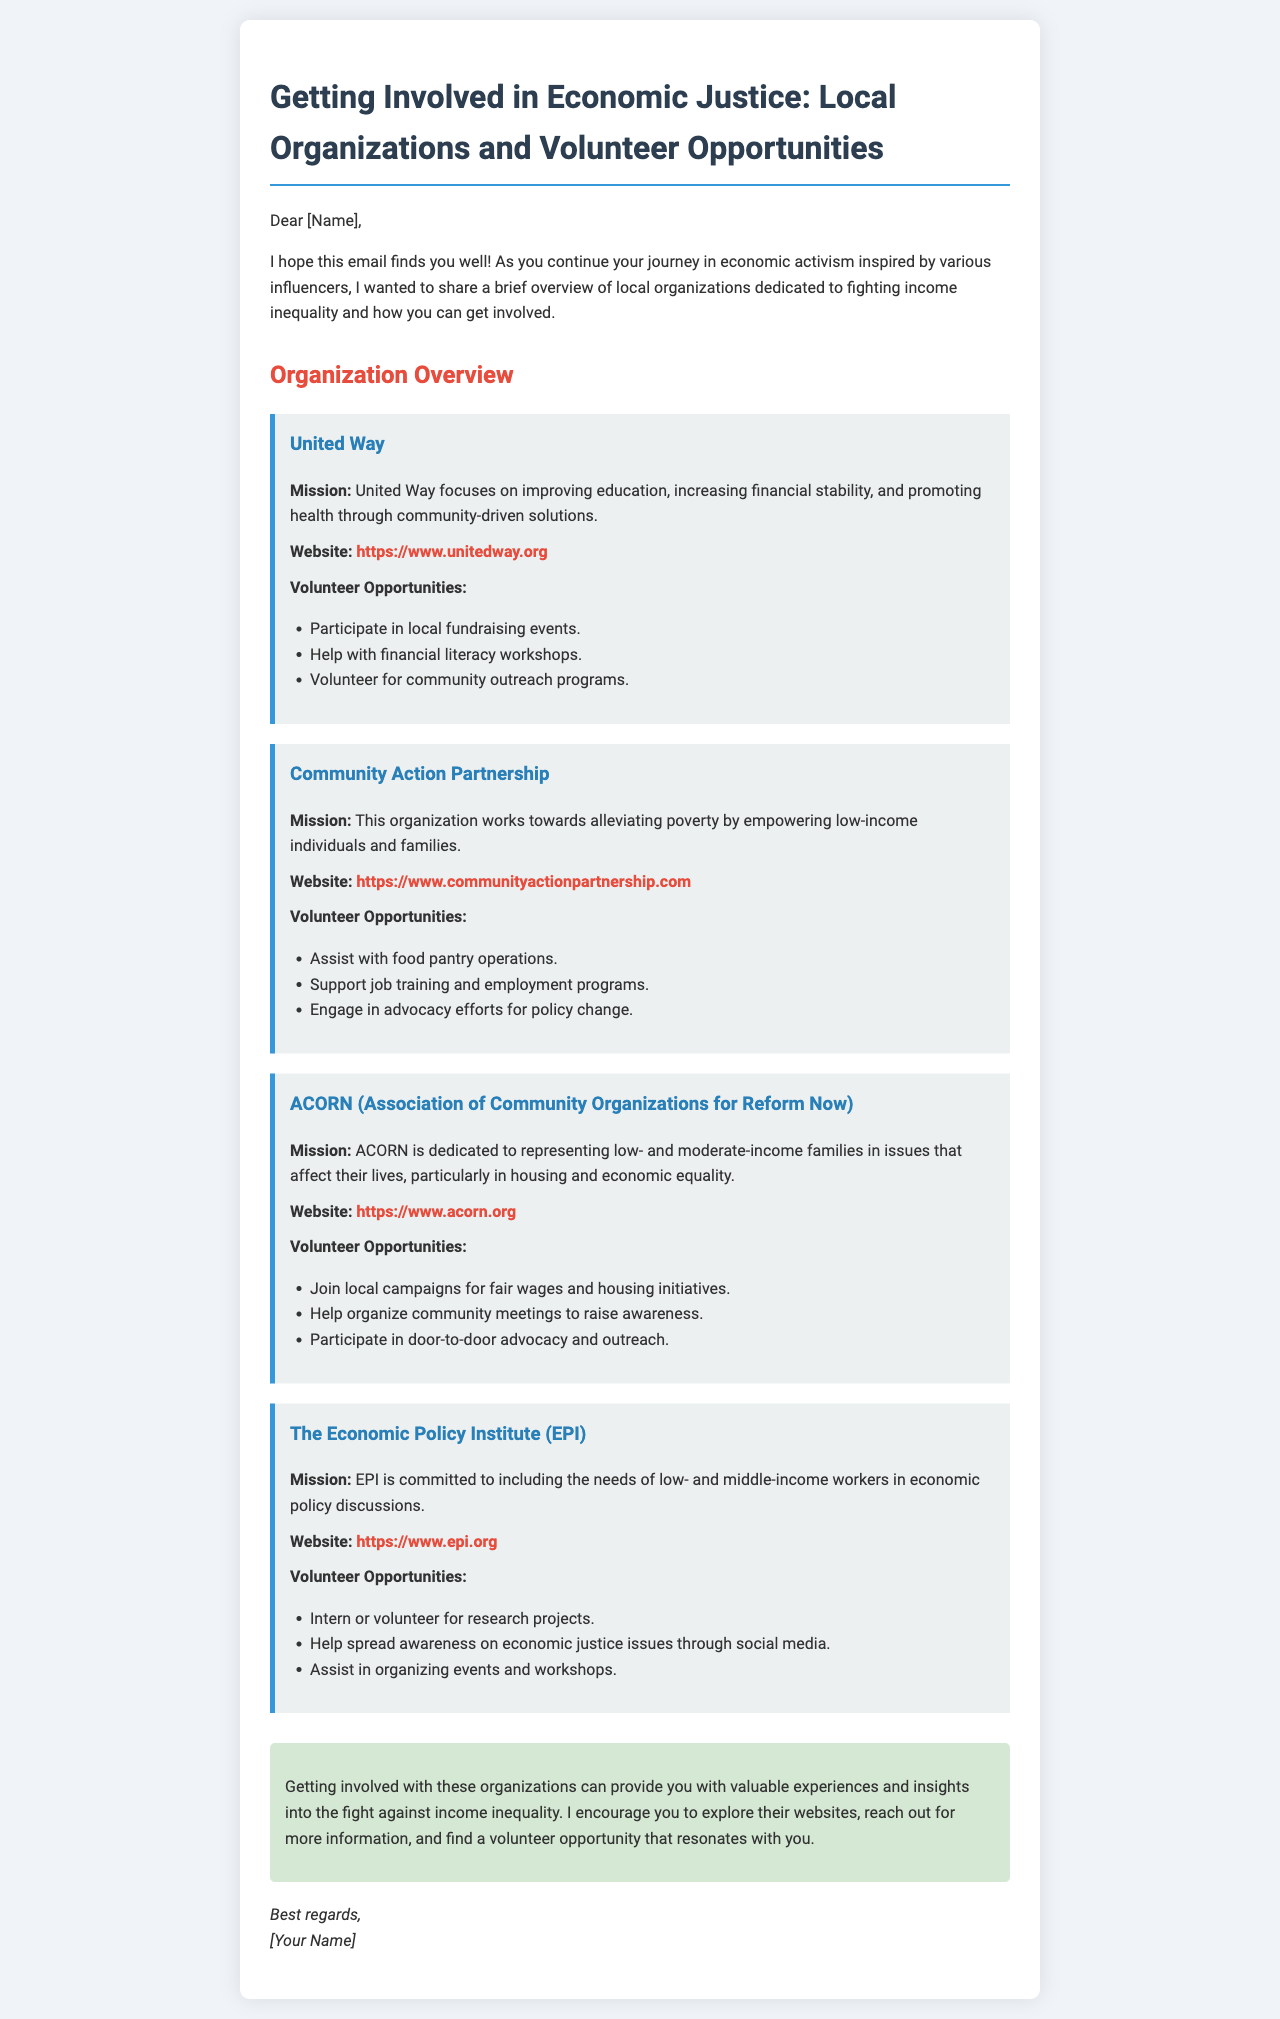What is the mission of United Way? The mission of United Way focuses on improving education, increasing financial stability, and promoting health through community-driven solutions.
Answer: Improving education, increasing financial stability, and promoting health What is offered as a volunteer opportunity by Community Action Partnership? One of the volunteer opportunities is to support job training and employment programs.
Answer: Support job training and employment programs Which organization is dedicated to representing low- and moderate-income families? ACORN is dedicated to representing low- and moderate-income families in issues that affect their lives, particularly in housing and economic equality.
Answer: ACORN How can volunteers raise awareness for ACORN? Volunteers can help organize community meetings to raise awareness.
Answer: Help organize community meetings What is the website for The Economic Policy Institute? The website for The Economic Policy Institute is where they share information on economic justice issues.
Answer: https://www.epi.org What type of volunteer opportunities does EPI provide? EPI provides opportunities to intern or volunteer for research projects.
Answer: Intern or volunteer for research projects What is the primary focus of Community Action Partnership? The primary focus is towards alleviating poverty by empowering low-income individuals and families.
Answer: Alleviating poverty by empowering low-income individuals and families What color is the background of the email container? The background color of the email container is white.
Answer: White What kind of events can you participate in with United Way? You can participate in local fundraising events.
Answer: Local fundraising events 